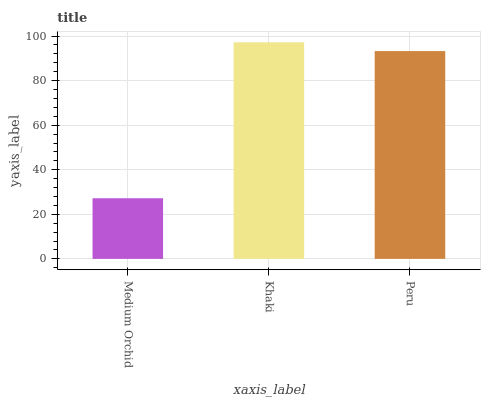Is Peru the minimum?
Answer yes or no. No. Is Peru the maximum?
Answer yes or no. No. Is Khaki greater than Peru?
Answer yes or no. Yes. Is Peru less than Khaki?
Answer yes or no. Yes. Is Peru greater than Khaki?
Answer yes or no. No. Is Khaki less than Peru?
Answer yes or no. No. Is Peru the high median?
Answer yes or no. Yes. Is Peru the low median?
Answer yes or no. Yes. Is Medium Orchid the high median?
Answer yes or no. No. Is Khaki the low median?
Answer yes or no. No. 